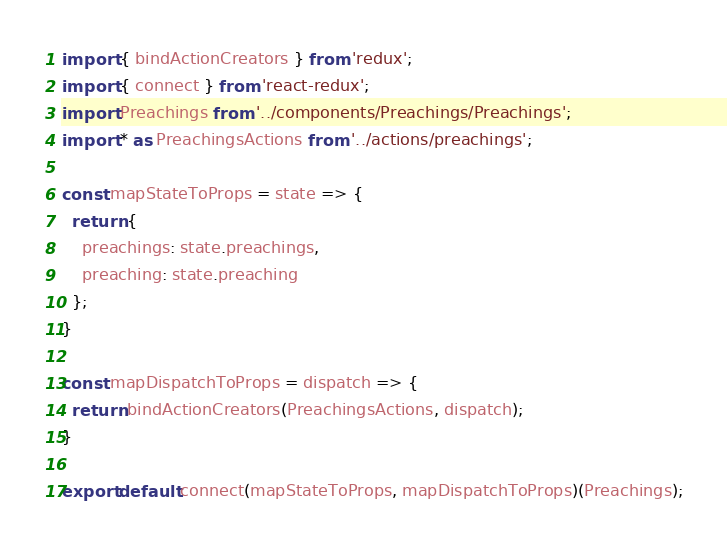<code> <loc_0><loc_0><loc_500><loc_500><_JavaScript_>import { bindActionCreators } from 'redux';
import { connect } from 'react-redux';
import Preachings from '../components/Preachings/Preachings';
import * as PreachingsActions from '../actions/preachings';

const mapStateToProps = state => {
  return {
    preachings: state.preachings,
    preaching: state.preaching
  };
}

const mapDispatchToProps = dispatch => {
  return bindActionCreators(PreachingsActions, dispatch);
}

export default connect(mapStateToProps, mapDispatchToProps)(Preachings);
</code> 